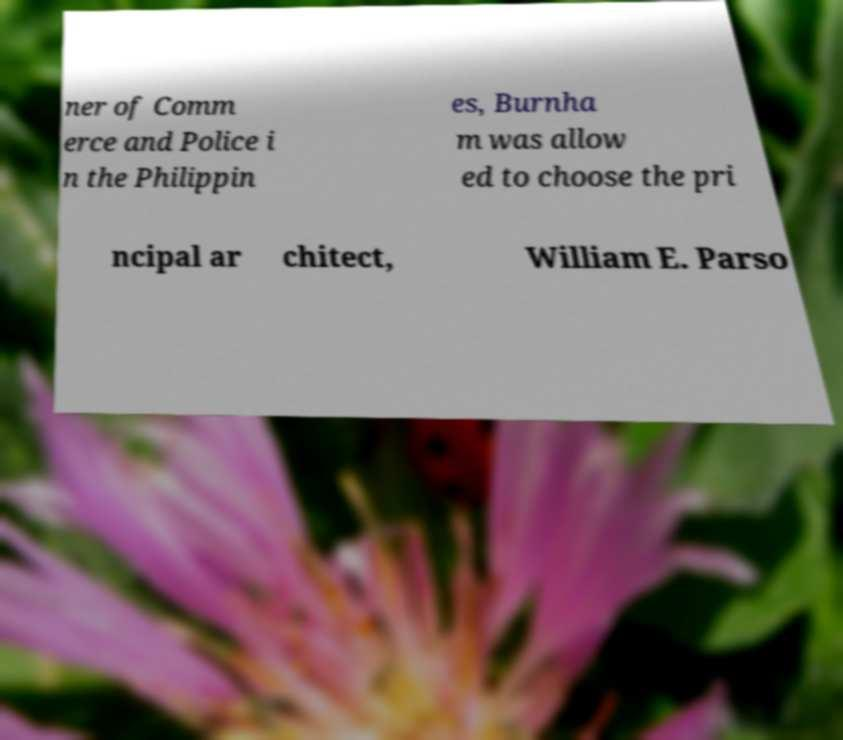Please identify and transcribe the text found in this image. ner of Comm erce and Police i n the Philippin es, Burnha m was allow ed to choose the pri ncipal ar chitect, William E. Parso 